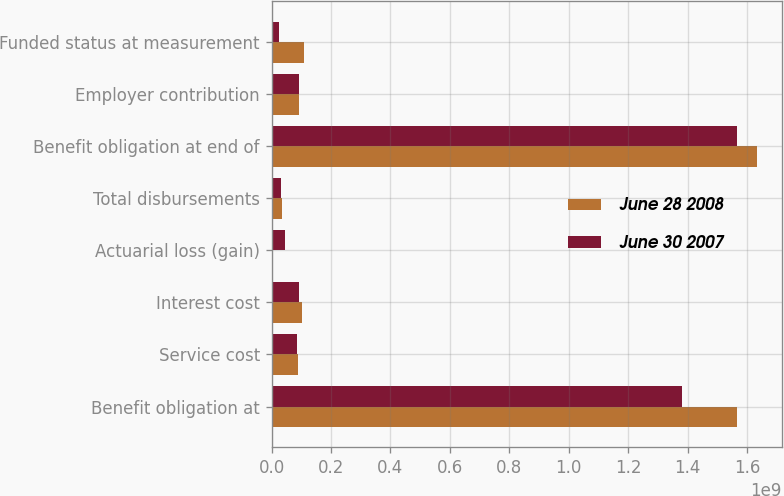Convert chart. <chart><loc_0><loc_0><loc_500><loc_500><stacked_bar_chart><ecel><fcel>Benefit obligation at<fcel>Service cost<fcel>Interest cost<fcel>Actuarial loss (gain)<fcel>Total disbursements<fcel>Benefit obligation at end of<fcel>Employer contribution<fcel>Funded status at measurement<nl><fcel>June 28 2008<fcel>1.56533e+09<fcel>9.057e+07<fcel>1.01218e+08<fcel>1.205e+06<fcel>3.4586e+07<fcel>1.63499e+09<fcel>9.267e+07<fcel>1.08415e+08<nl><fcel>June 30 2007<fcel>1.38141e+09<fcel>8.4654e+07<fcel>9.1311e+07<fcel>4.6463e+07<fcel>3.1106e+07<fcel>1.56533e+09<fcel>9.0836e+07<fcel>2.5362e+07<nl></chart> 